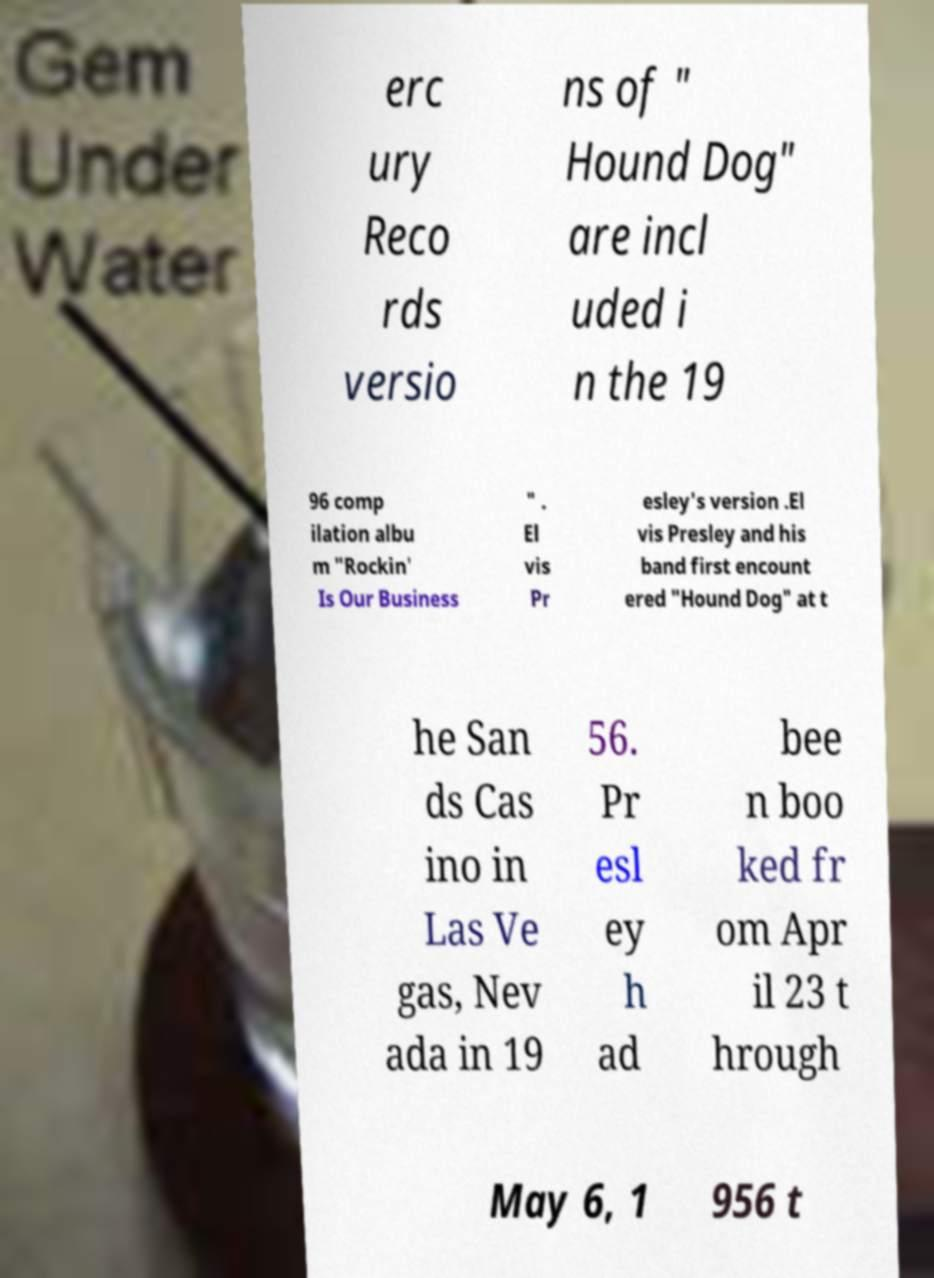For documentation purposes, I need the text within this image transcribed. Could you provide that? erc ury Reco rds versio ns of " Hound Dog" are incl uded i n the 19 96 comp ilation albu m "Rockin' Is Our Business " . El vis Pr esley's version .El vis Presley and his band first encount ered "Hound Dog" at t he San ds Cas ino in Las Ve gas, Nev ada in 19 56. Pr esl ey h ad bee n boo ked fr om Apr il 23 t hrough May 6, 1 956 t 